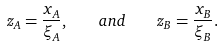<formula> <loc_0><loc_0><loc_500><loc_500>z _ { A } = \frac { x _ { A } } { \xi _ { A } } , \quad a n d \quad z _ { B } = \frac { x _ { B } } { \xi _ { B } } .</formula> 